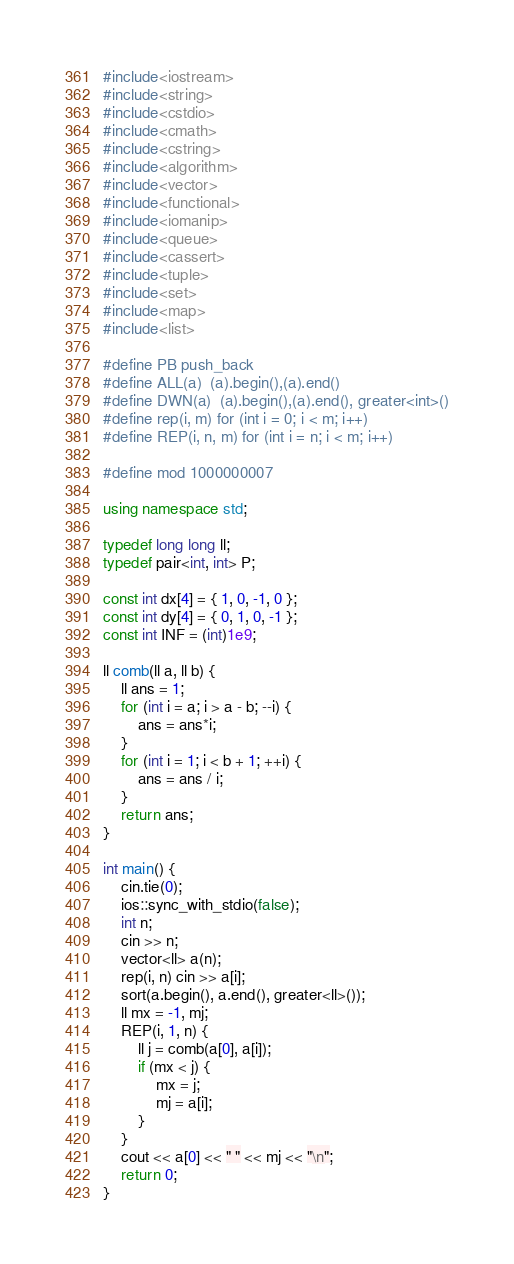<code> <loc_0><loc_0><loc_500><loc_500><_C++_>#include<iostream>
#include<string>
#include<cstdio>
#include<cmath>
#include<cstring>
#include<algorithm>
#include<vector>
#include<functional>
#include<iomanip>
#include<queue>
#include<cassert>
#include<tuple>
#include<set>
#include<map>
#include<list>

#define PB push_back
#define ALL(a)  (a).begin(),(a).end()
#define DWN(a)  (a).begin(),(a).end(), greater<int>()
#define rep(i, m) for (int i = 0; i < m; i++)
#define REP(i, n, m) for (int i = n; i < m; i++)

#define mod 1000000007

using namespace std;

typedef long long ll;
typedef pair<int, int> P;

const int dx[4] = { 1, 0, -1, 0 };
const int dy[4] = { 0, 1, 0, -1 };
const int INF = (int)1e9;

ll comb(ll a, ll b) {
	ll ans = 1;
	for (int i = a; i > a - b; --i) {
		ans = ans*i;
	}
	for (int i = 1; i < b + 1; ++i) {
		ans = ans / i;
	}
	return ans;
}

int main() { 
	cin.tie(0);
	ios::sync_with_stdio(false);
	int n;
	cin >> n;
	vector<ll> a(n);
	rep(i, n) cin >> a[i];
	sort(a.begin(), a.end(), greater<ll>());
	ll mx = -1, mj;
	REP(i, 1, n) {
		ll j = comb(a[0], a[i]);
		if (mx < j) {
			mx = j;
			mj = a[i];
		}
	}
	cout << a[0] << " " << mj << "\n";
	return 0;
}</code> 